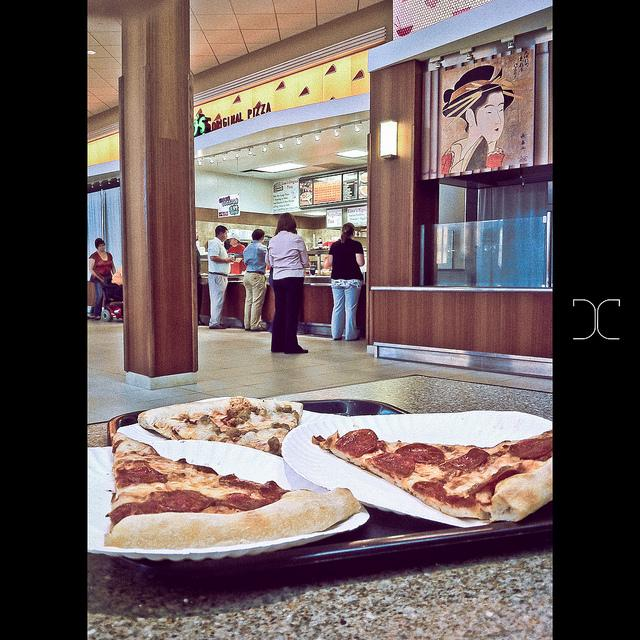Where is this taking place? food court 